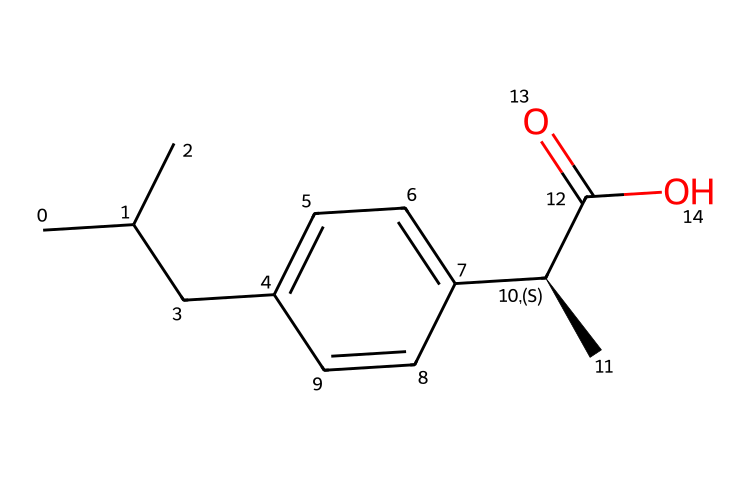What is the molecular formula of ibuprofen? By analyzing the SMILES representation, count the carbon (C), hydrogen (H), and oxygen (O) atoms present. There are 13 carbons, 18 hydrogens, and 2 oxygens. Therefore, the molecular formula is C13H18O2.
Answer: C13H18O2 How many chiral centers are in ibuprofen? In the structure, we identify a chiral carbon atom marked by the '@' symbol in the SMILES, indicating it has four different substituents attached. There is only one chiral center in ibuprofen.
Answer: 1 What functional groups are present in ibuprofen? By examining the structure, we can identify a carboxylic acid group (C(=O)O) and an alkane (C-C) chain. The presence of the carboxylic acid is significant for its acidity and pain-relieving properties.
Answer: carboxylic acid, alkane What is the total number of rings in ibuprofen’s molecular structure? Analyzing the structure shows that there is a single six-membered aromatic ring (benzene ring), which is characteristic of ibuprofen. No other rings are present.
Answer: 1 What type of compound is ibuprofen classified as? Based on its structure, ibuprofen is classified as a non-steroidal anti-inflammatory drug (NSAID), characterized by the presence of the carboxylic acid and its effects on inflammation.
Answer: NSAID Which part of the ibuprofen structure contributes to its anti-inflammatory properties? The carboxylic acid functional group (-COOH) is predominantly responsible for its anti-inflammatory activity because it allows interaction with enzymes and receptors in the body involved in pain and inflammation.
Answer: carboxylic acid 